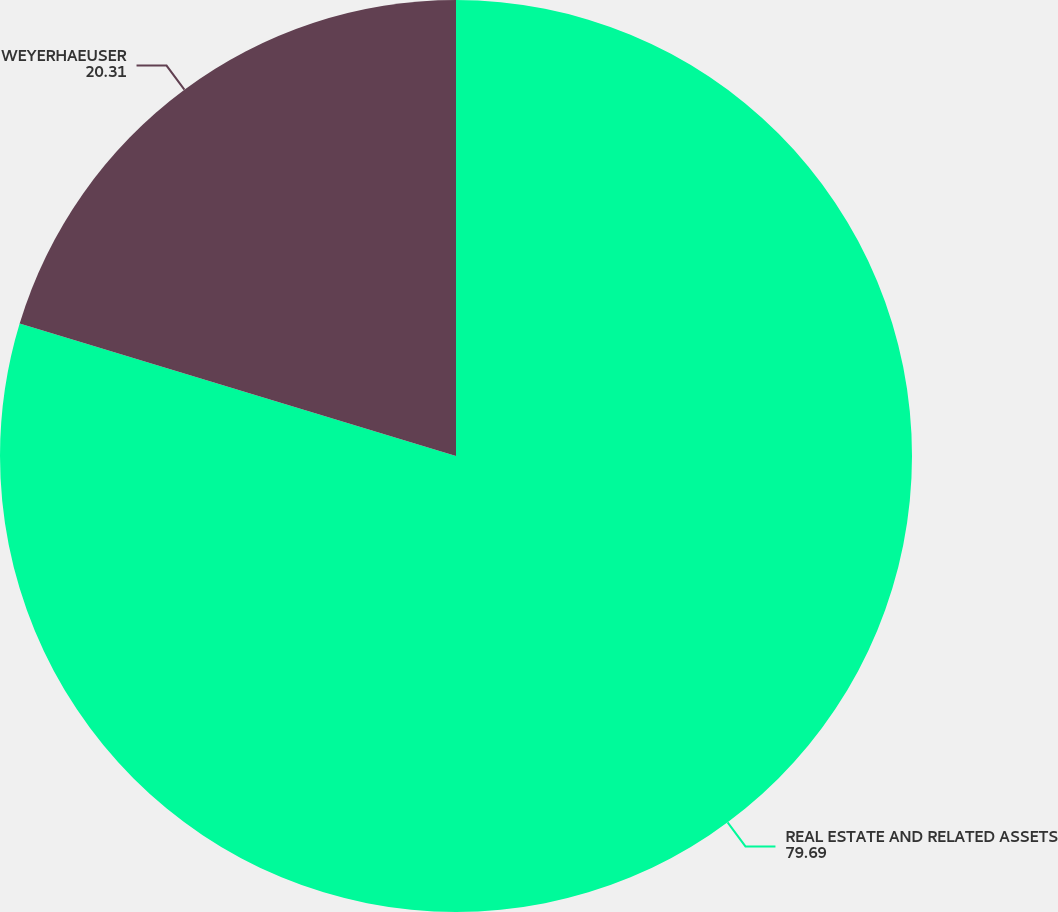Convert chart to OTSL. <chart><loc_0><loc_0><loc_500><loc_500><pie_chart><fcel>REAL ESTATE AND RELATED ASSETS<fcel>WEYERHAEUSER<nl><fcel>79.69%<fcel>20.31%<nl></chart> 